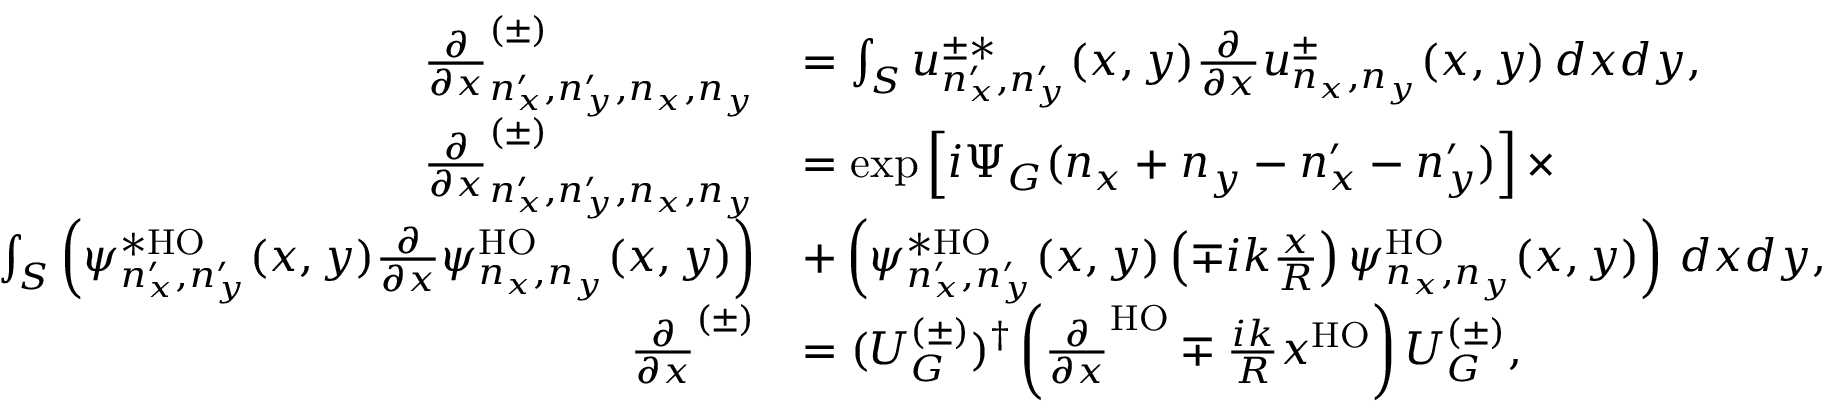Convert formula to latex. <formula><loc_0><loc_0><loc_500><loc_500>\begin{array} { r l } { \frac { \partial } { \partial x } _ { n _ { x } ^ { \prime } , n _ { y } ^ { \prime } , n _ { x } , n _ { y } } ^ { ( \pm ) } } & { = \int _ { S } u _ { n _ { x } ^ { \prime } , n _ { y } ^ { \prime } } ^ { \pm * } ( x , y ) \frac { \partial } { \partial x } u _ { n _ { x } , n _ { y } } ^ { \pm } ( x , y ) \, d x d y , } \\ { \frac { \partial } { \partial x } _ { n _ { x } ^ { \prime } , n _ { y } ^ { \prime } , n _ { x } , n _ { y } } ^ { ( \pm ) } } & { = \exp \left [ i \Psi _ { G } ( n _ { x } + n _ { y } - n _ { x } ^ { \prime } - n _ { y } ^ { \prime } ) \right ] \times } \\ { \int _ { S } \left ( \psi _ { n _ { x } ^ { \prime } , n _ { y } ^ { \prime } } ^ { * H O } ( x , y ) \frac { \partial } { \partial x } \psi _ { n _ { x } , n _ { y } } ^ { H O } ( x , y ) \right ) } & { + \left ( \psi _ { n _ { x } ^ { \prime } , n _ { y } ^ { \prime } } ^ { * H O } ( x , y ) \left ( \mp i k \frac { x } { R } \right ) \psi _ { n _ { x } , n _ { y } } ^ { H O } ( x , y ) \right ) \, d x d y , } \\ { \frac { \partial } { \partial x } ^ { ( \pm ) } } & { = ( U _ { G } ^ { ( \pm ) } ) ^ { \dag } \left ( \frac { \partial } { \partial x } ^ { H O } \mp \frac { i k } { R } x ^ { H O } \right ) U _ { G } ^ { ( \pm ) } , } \end{array}</formula> 